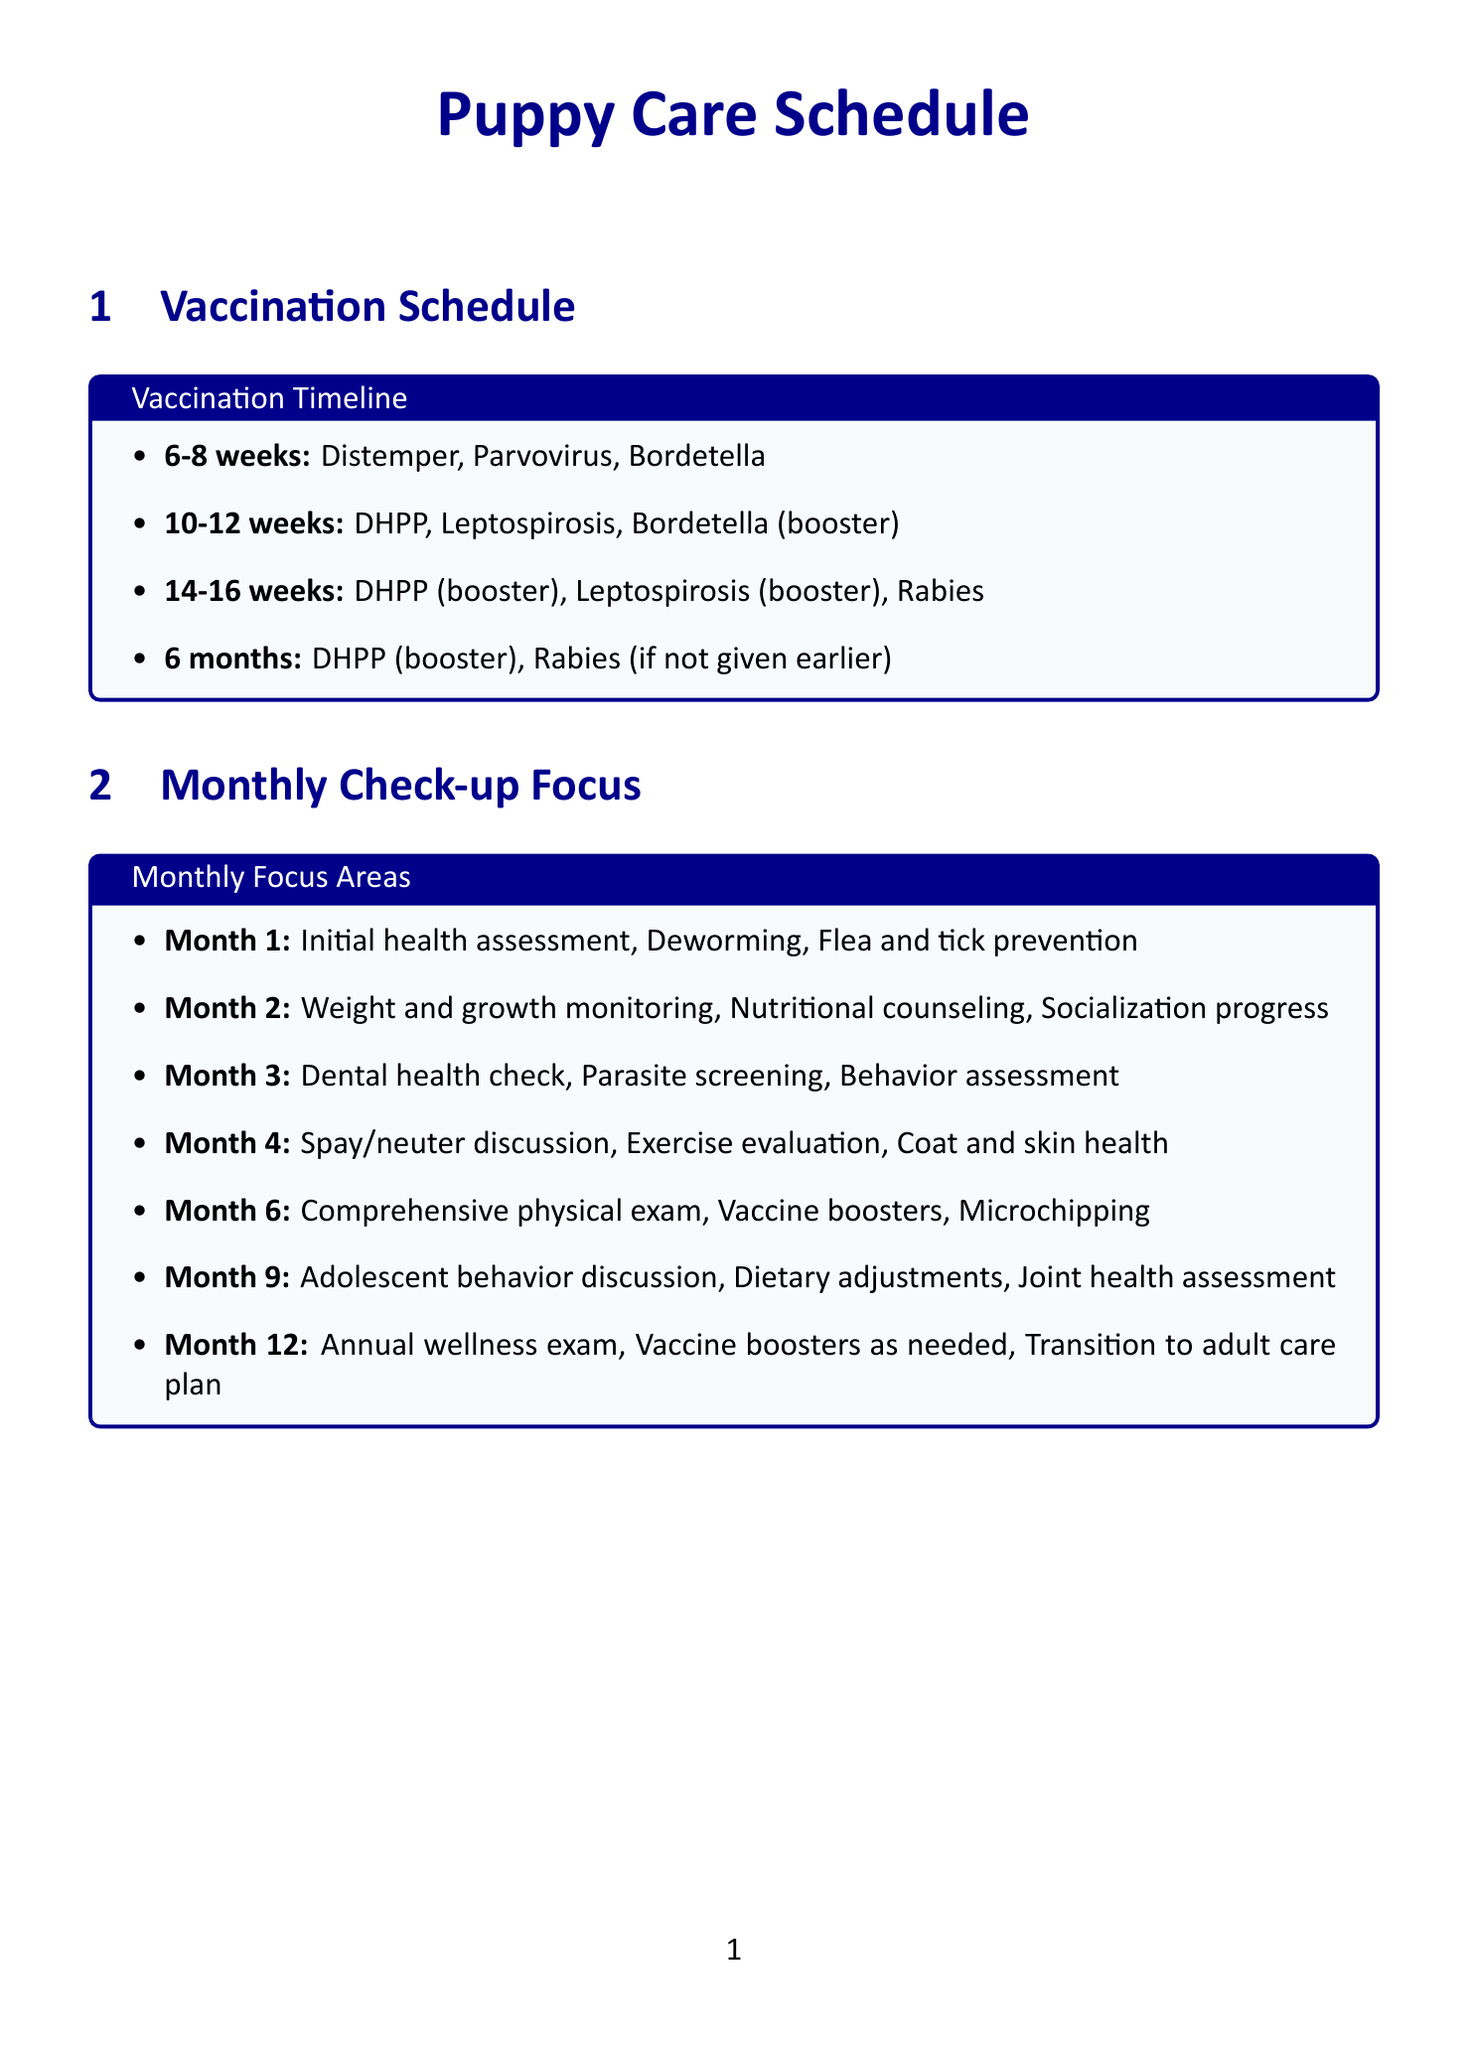what vaccines are given at 6-8 weeks? The document specifies that at 6-8 weeks, the vaccines given are Distemper, Parvovirus, and Bordetella.
Answer: Distemper, Parvovirus, Bordetella what should be monitored during the first month? The focus areas for the first month include initial health assessment, deworming, and flea and tick prevention, all of which should be monitored.
Answer: Initial health assessment, deworming, flea and tick prevention what is discussed during the fourth month check-up? The month 4 focus areas include spay/neuter discussion, exercise evaluation, and coat and skin health.
Answer: Spay/neuter discussion, exercise evaluation, coat and skin health how many vaccines are given at 10-12 weeks? At 10-12 weeks, there are three types of vaccines listed: DHPP, Leptospirosis, and Bordetella (booster).
Answer: Three what additional health screening is recommended besides heartworm test? The document lists several recommended screenings, including fecal examination, blood work (CBC and chemistry panel), and urinalysis, in addition to heartworm test.
Answer: Fecal examination, blood work, urinalysis what is the age for the rabies vaccine if not given earlier? According to the vaccination schedule, the rabies vaccine is given at 6 months if it was not administered earlier.
Answer: 6 months what is the focus for the ninth month check-up? The focus areas for the ninth month include adolescent behavior discussion, dietary adjustments, and joint health assessment.
Answer: Adolescent behavior discussion, dietary adjustments, joint health assessment when should a comprehensive physical exam be conducted? The document states that a comprehensive physical exam should be conducted during the sixth month check-up.
Answer: Month 6 what is recommended for dental care? For dental care, the document recommends Greenies Dental Treats, Virbac C.E.T. Enzymatic Toothpaste, and water additives like Tropiclean Fresh Breath.
Answer: Greenies Dental Treats, Virbac C.E.T. Enzymatic Toothpaste, water additives like Tropiclean Fresh Breath 